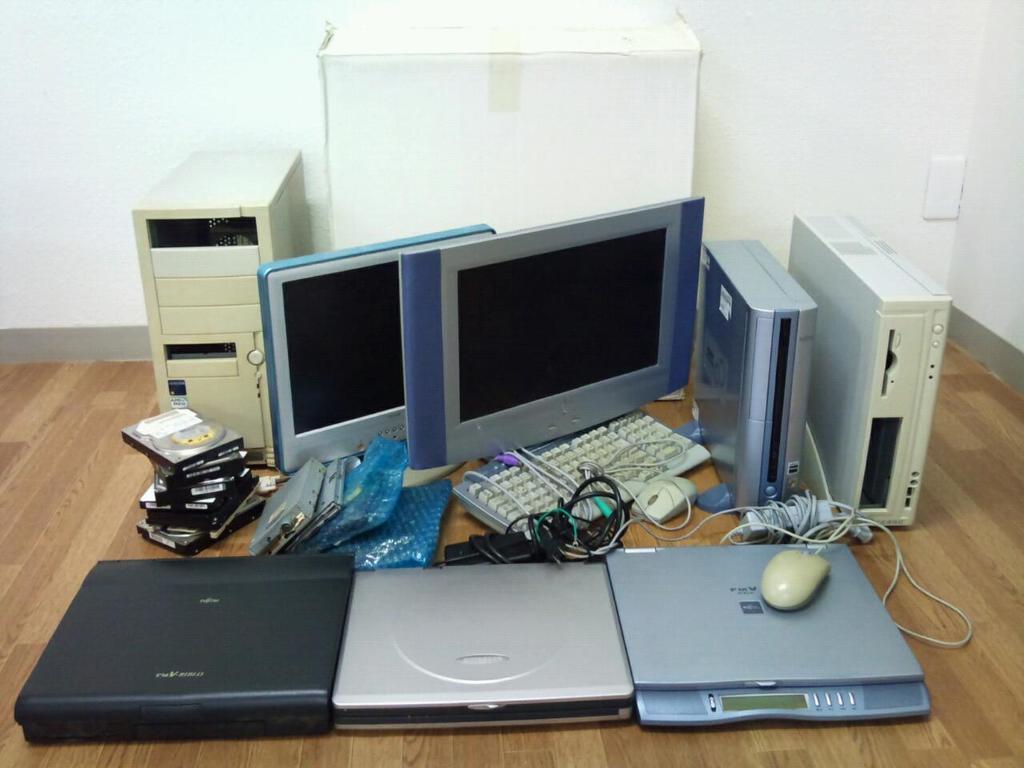Could you give a brief overview of what you see in this image? This Image consists of computers, DVD players, Mouse, monitors, keyboards, wires, CD, CPU, and a box in the back side. 